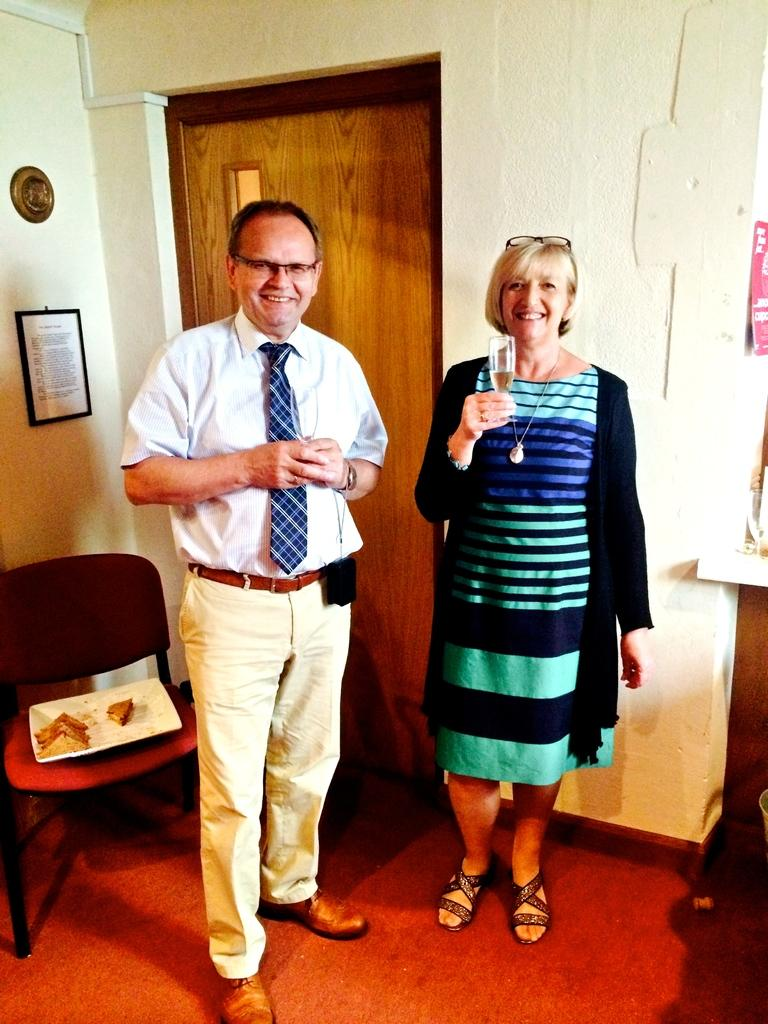How many people are in the image? There is a man and a woman in the image. Where are the man and woman located in the image? The man and woman are in the center of the image. What can be seen in the background of the image? There is a door in the background of the image. What object is on the left side of the image? There is a chair on the left side of the image. What type of swing can be seen in the image? There is no swing present in the image. What type of trade is being conducted in the image? There is no trade being conducted in the image; it features a man and a woman in the center. 